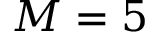Convert formula to latex. <formula><loc_0><loc_0><loc_500><loc_500>M = 5</formula> 